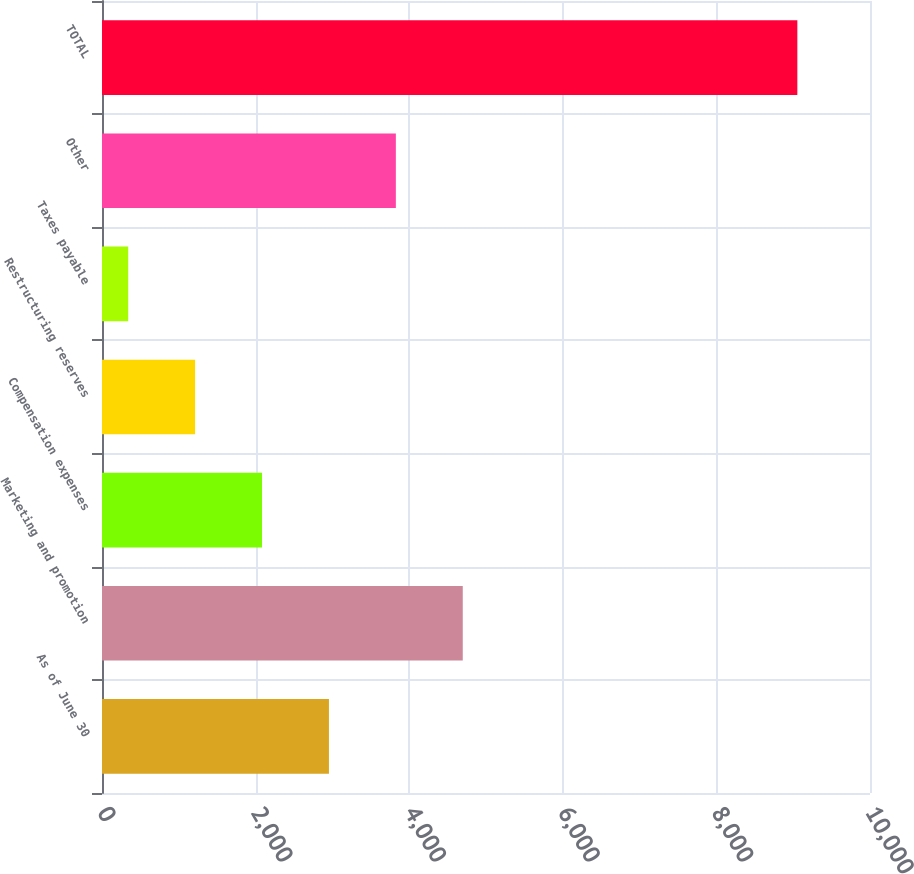<chart> <loc_0><loc_0><loc_500><loc_500><bar_chart><fcel>As of June 30<fcel>Marketing and promotion<fcel>Compensation expenses<fcel>Restructuring reserves<fcel>Taxes payable<fcel>Other<fcel>TOTAL<nl><fcel>2954.9<fcel>4697.5<fcel>2083.6<fcel>1212.3<fcel>341<fcel>3826.2<fcel>9054<nl></chart> 